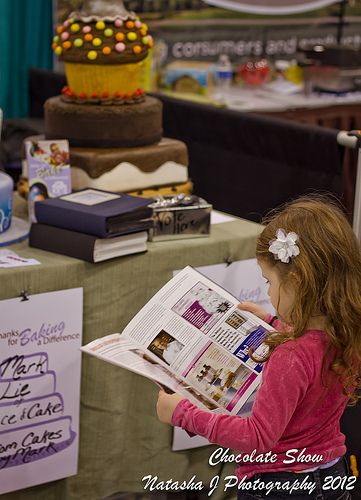Is the water bottle in the bottom or in the top of the picture? The water bottle is located near the top of the picture, resting on a table. 